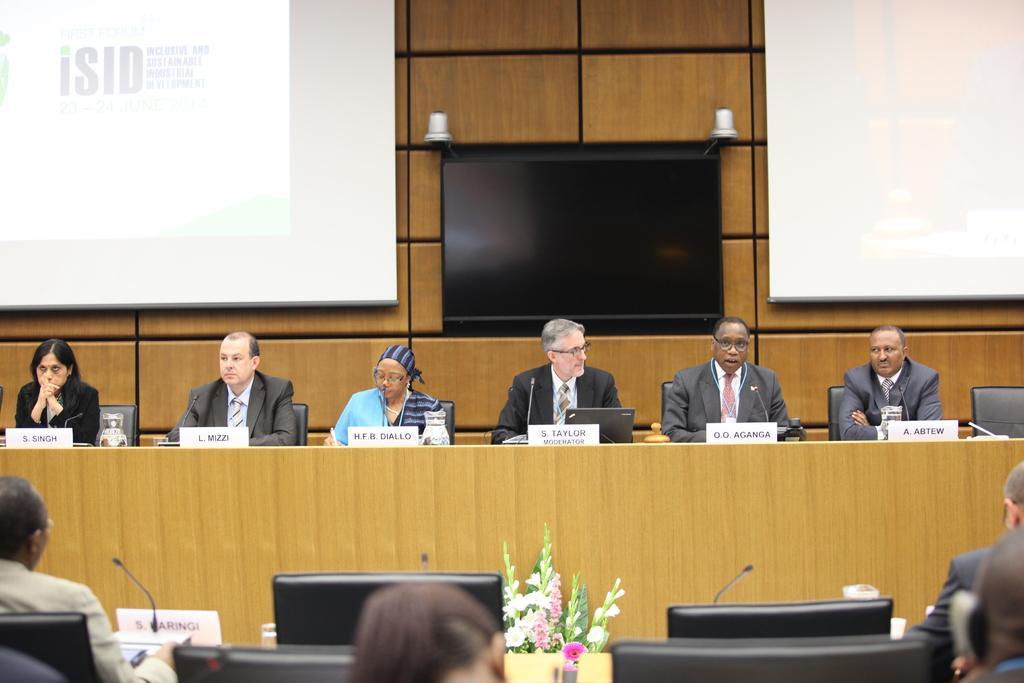In one or two sentences, can you explain what this image depicts? People are seated at the front. There are screens, microphones and name plates. There is a flower bouquet at the center. Few people are seated back. A woman at the center is wearing a blue dress, other people are wearing suit. There are name plates, microphones, a glass of water and a laptop in front of them. There is a screen at the center back and 2 projector displays on the either sides of the screen. 